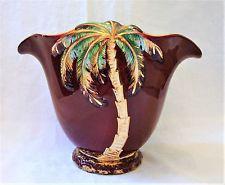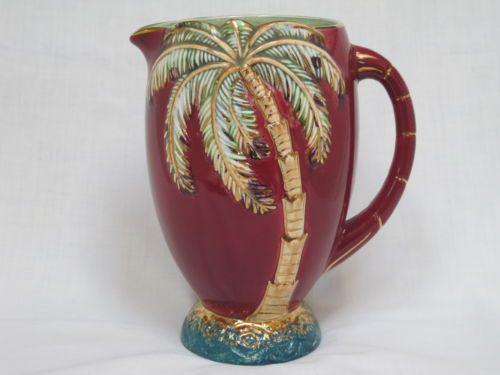The first image is the image on the left, the second image is the image on the right. Considering the images on both sides, is "There is at least 1 blue decorative vase with a palm tree on it." valid? Answer yes or no. No. The first image is the image on the left, the second image is the image on the right. Given the left and right images, does the statement "the right image contains a pitcher with a handle" hold true? Answer yes or no. Yes. 